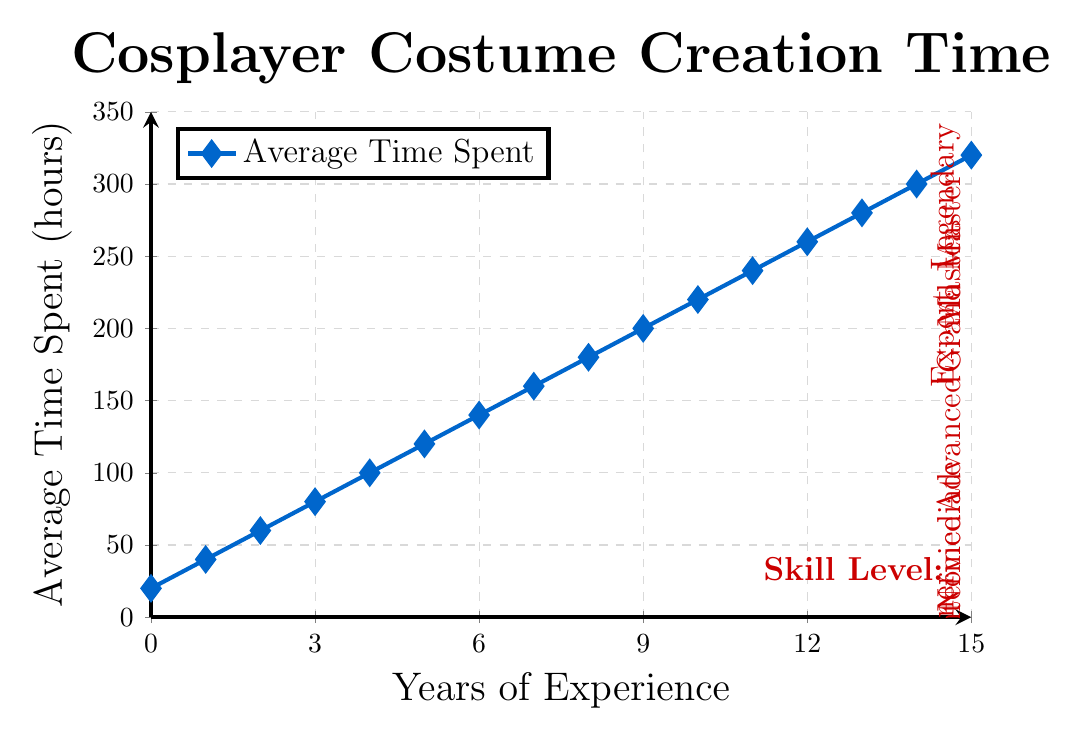What's the average time spent on costume creation at the Novice level? The Novice level corresponds to 1 year of experience, where the average time spent is 40 hours.
Answer: 40 hours How much more time does a Legendary cosplayer spend on costume creation compared to an Intermediate cosplayer? Legendary cosplayer (260 and 280 hours) and Intermediate cosplayer (60 and 80 hours). Therefore, the difference: lowest: 260 - 60 = 200 hours, highest: 280 - 80 = 200 hours. The range is from 200 to 200 hours more.
Answer: 200 hours At which year does the average time spent on costume creation first surpass 200 hours? From the chart, the average time first surpasses 200 hours at the 10-year mark with a time of 220 hours.
Answer: 10 years Which skill level has the largest time increment compared to the previous skill level? The largest increment occurs between Grand Master (220-240 hours) and Legendary (260-280 hours). The increment is 20 hours.
Answer: Grand Master to Legendary Across how many years does the "Expert" skill level span according to the chart? Expert skill level spans from the 6th year to the end of the 7th year, which is a total of 2 years.
Answer: 2 years What is the average time spent on costume creation over the first 5 years? Average time over the first 5 years = (20 + 40 + 60 + 80 + 100) / 5 = 60 hours.
Answer: 60 hours What are the trend and rate of increase in average time spent as cosplayers become more experienced? The trend shows a consistent increase in average time spent as years of experience increase. The rate gains an increment of 20 hours for each additional year. Starting from 20 hours to 320 hours over 15 years indicates both a steady rise in commitment and expertise.
Answer: Steady increase At what year and skill level is the average time spent 180 hours? According to the data, 180 hours is spent in the 8th year at the "Master" level.
Answer: 8 years, Master 